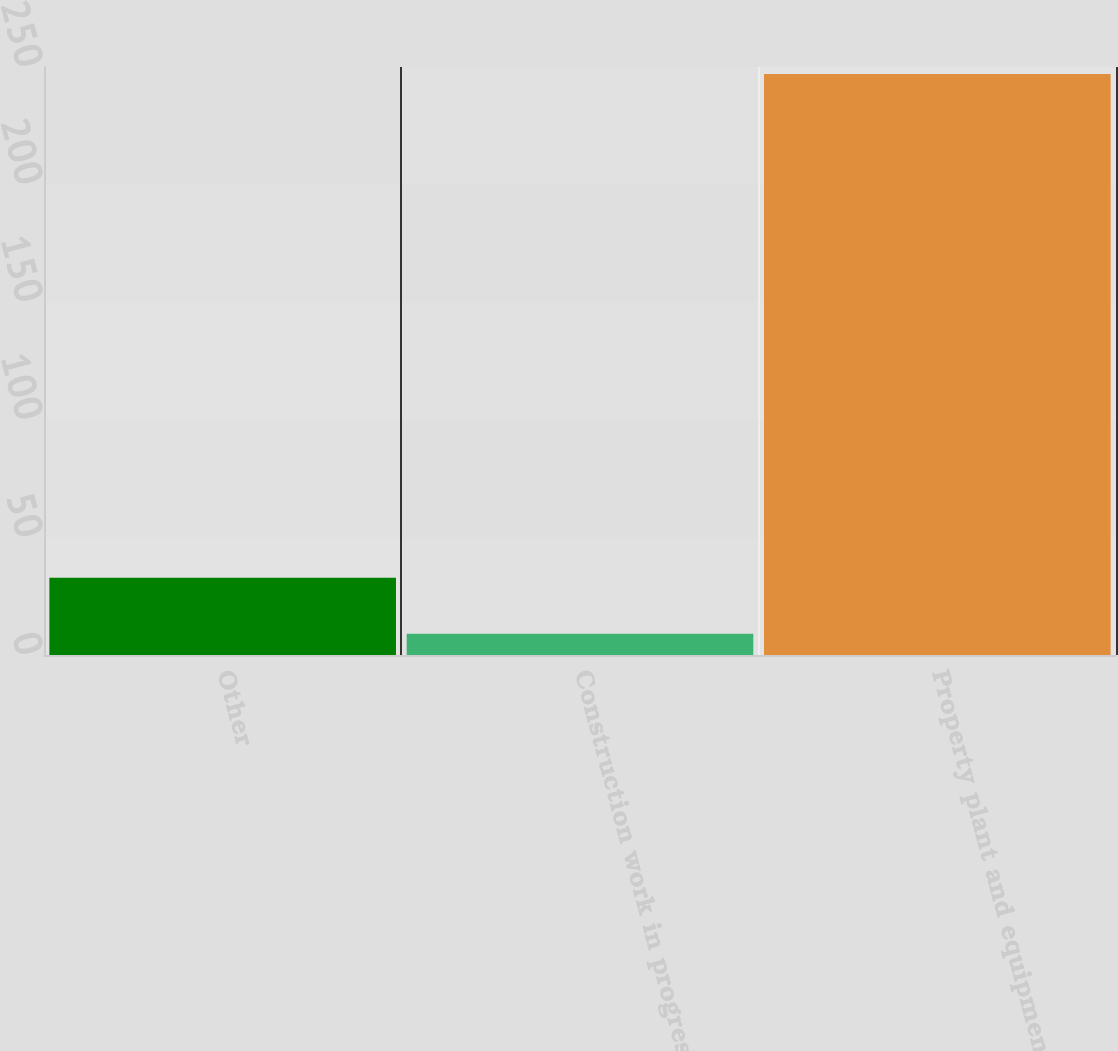Convert chart to OTSL. <chart><loc_0><loc_0><loc_500><loc_500><bar_chart><fcel>Other<fcel>Construction work in progress<fcel>Property plant and equipment -<nl><fcel>32.8<fcel>9<fcel>247<nl></chart> 